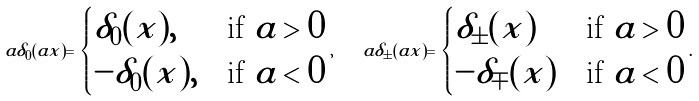Convert formula to latex. <formula><loc_0><loc_0><loc_500><loc_500>a \delta _ { 0 } ( a x ) = \begin{cases} \delta _ { 0 } ( x ) , & \text {if $a>0$} \\ - \delta _ { 0 } ( x ) , & \text {if $a<0$} \end{cases} , \quad a \delta _ { \pm } ( a x ) = \begin{cases} \delta _ { \pm } ( x ) & \text {if $a>0$} \\ - \delta _ { \mp } ( x ) & \text {if $a<0$} \end{cases} .</formula> 